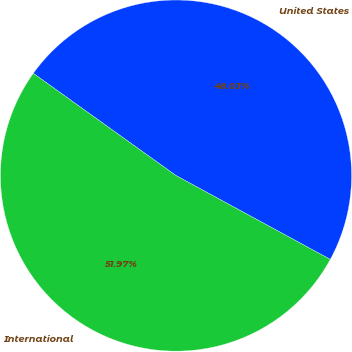Convert chart to OTSL. <chart><loc_0><loc_0><loc_500><loc_500><pie_chart><fcel>United States<fcel>International<nl><fcel>48.03%<fcel>51.97%<nl></chart> 